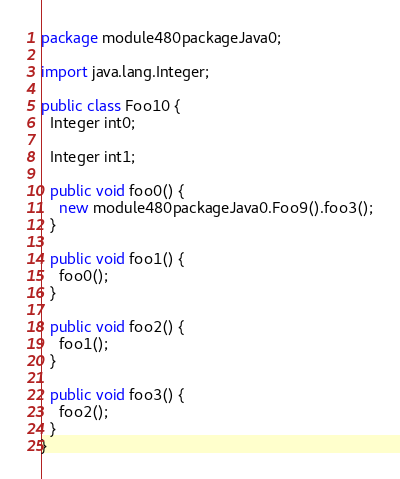Convert code to text. <code><loc_0><loc_0><loc_500><loc_500><_Java_>package module480packageJava0;

import java.lang.Integer;

public class Foo10 {
  Integer int0;

  Integer int1;

  public void foo0() {
    new module480packageJava0.Foo9().foo3();
  }

  public void foo1() {
    foo0();
  }

  public void foo2() {
    foo1();
  }

  public void foo3() {
    foo2();
  }
}
</code> 